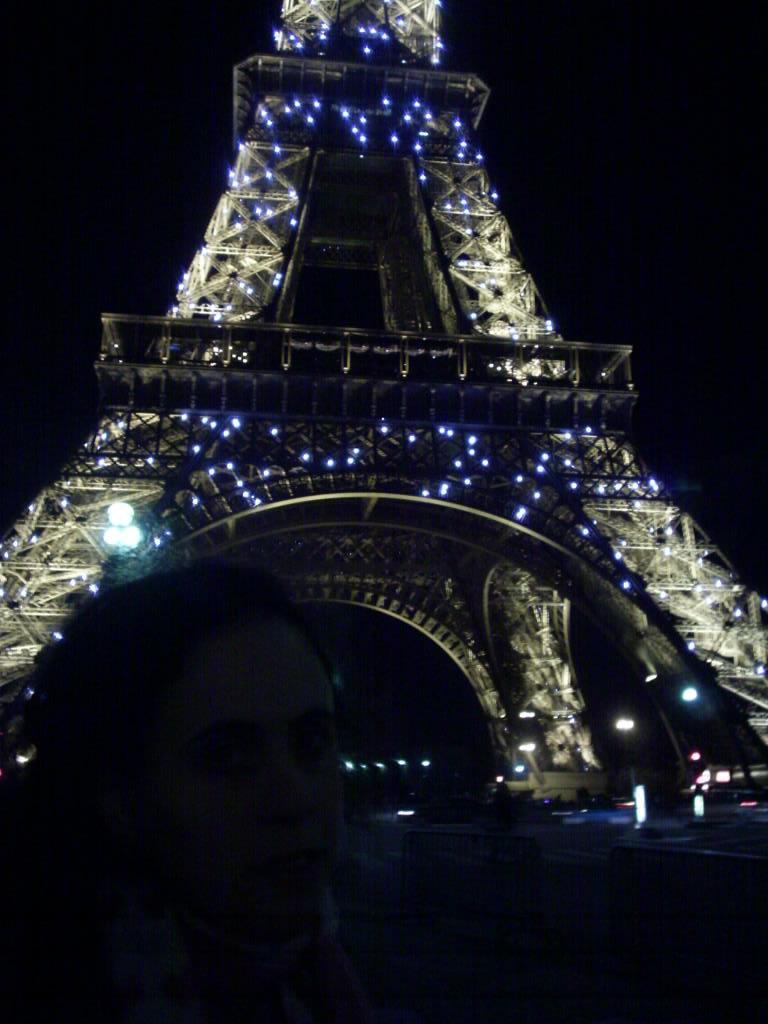Can you describe this image briefly? Here we can see a tower and lights. There is a dark background. 